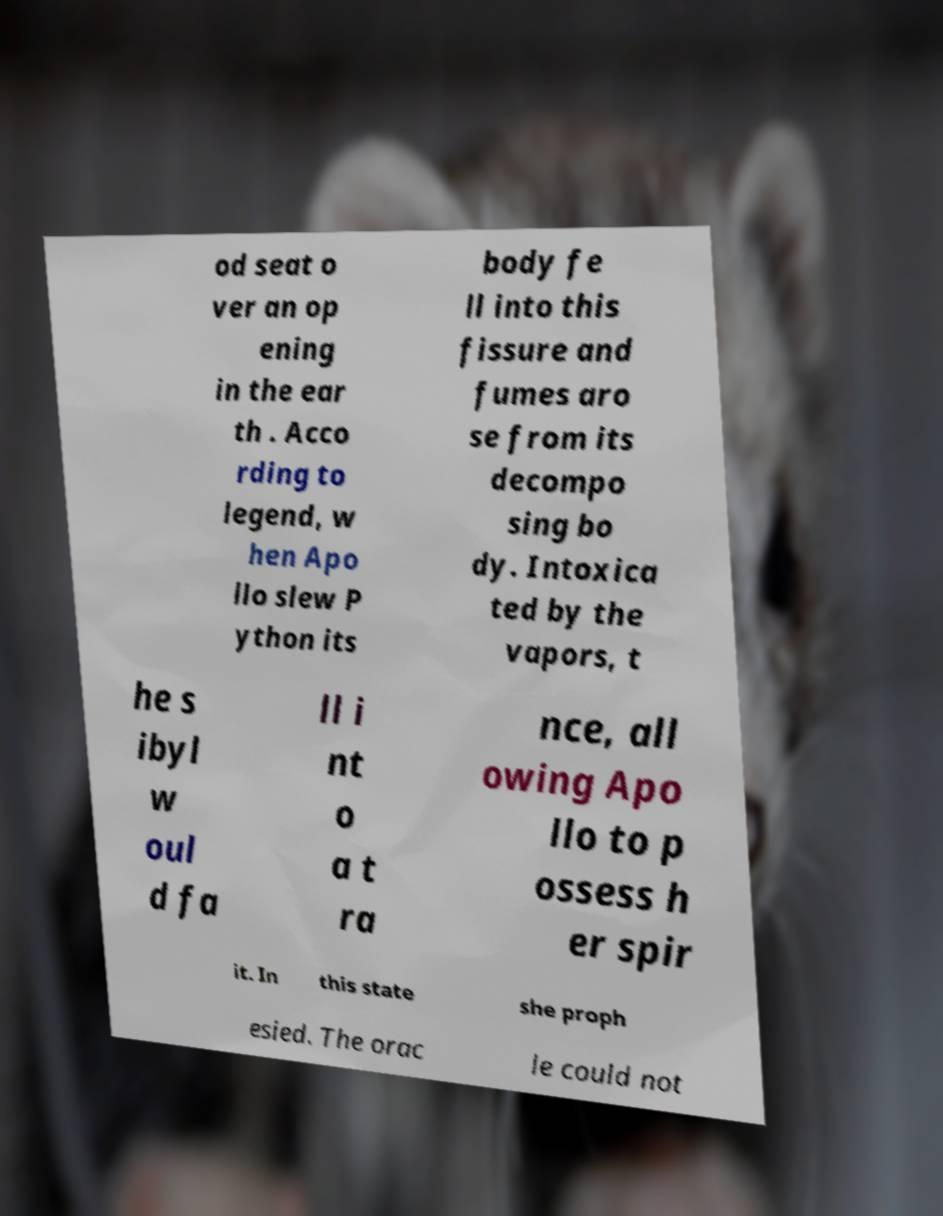Can you read and provide the text displayed in the image?This photo seems to have some interesting text. Can you extract and type it out for me? od seat o ver an op ening in the ear th . Acco rding to legend, w hen Apo llo slew P ython its body fe ll into this fissure and fumes aro se from its decompo sing bo dy. Intoxica ted by the vapors, t he s ibyl w oul d fa ll i nt o a t ra nce, all owing Apo llo to p ossess h er spir it. In this state she proph esied. The orac le could not 